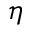Convert formula to latex. <formula><loc_0><loc_0><loc_500><loc_500>\eta</formula> 